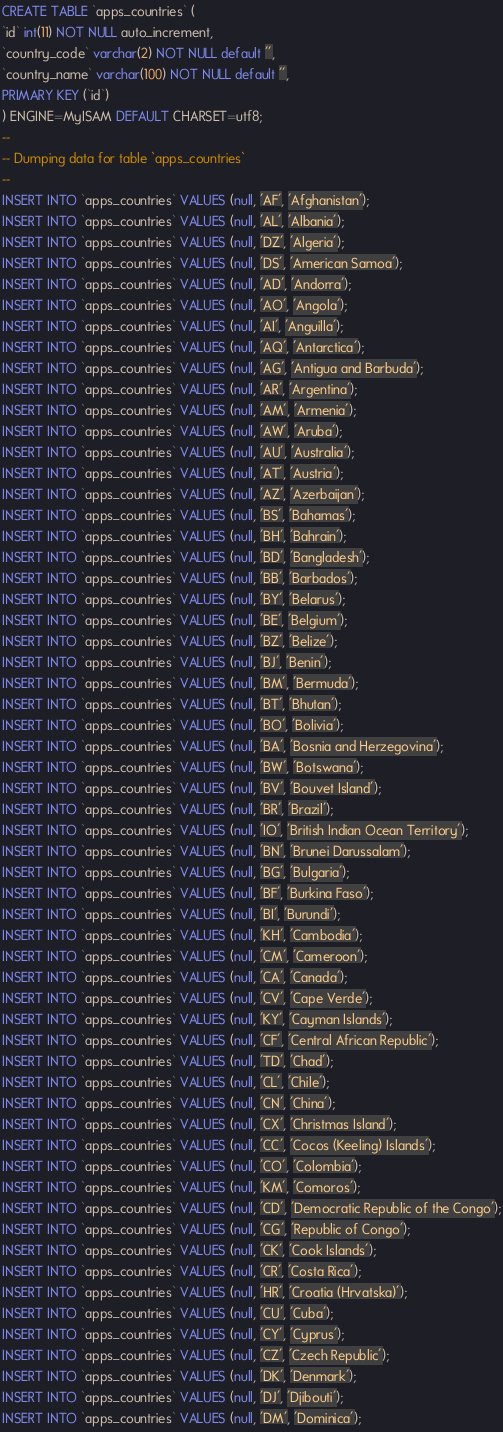<code> <loc_0><loc_0><loc_500><loc_500><_SQL_>CREATE TABLE `apps_countries` (
`id` int(11) NOT NULL auto_increment,
`country_code` varchar(2) NOT NULL default '',
`country_name` varchar(100) NOT NULL default '',
PRIMARY KEY (`id`)
) ENGINE=MyISAM DEFAULT CHARSET=utf8;
-- 
-- Dumping data for table `apps_countries`
-- 
INSERT INTO `apps_countries` VALUES (null, 'AF', 'Afghanistan');
INSERT INTO `apps_countries` VALUES (null, 'AL', 'Albania');
INSERT INTO `apps_countries` VALUES (null, 'DZ', 'Algeria');
INSERT INTO `apps_countries` VALUES (null, 'DS', 'American Samoa');
INSERT INTO `apps_countries` VALUES (null, 'AD', 'Andorra');
INSERT INTO `apps_countries` VALUES (null, 'AO', 'Angola');
INSERT INTO `apps_countries` VALUES (null, 'AI', 'Anguilla');
INSERT INTO `apps_countries` VALUES (null, 'AQ', 'Antarctica');
INSERT INTO `apps_countries` VALUES (null, 'AG', 'Antigua and Barbuda');
INSERT INTO `apps_countries` VALUES (null, 'AR', 'Argentina');
INSERT INTO `apps_countries` VALUES (null, 'AM', 'Armenia');
INSERT INTO `apps_countries` VALUES (null, 'AW', 'Aruba');
INSERT INTO `apps_countries` VALUES (null, 'AU', 'Australia');
INSERT INTO `apps_countries` VALUES (null, 'AT', 'Austria');
INSERT INTO `apps_countries` VALUES (null, 'AZ', 'Azerbaijan');
INSERT INTO `apps_countries` VALUES (null, 'BS', 'Bahamas');
INSERT INTO `apps_countries` VALUES (null, 'BH', 'Bahrain');
INSERT INTO `apps_countries` VALUES (null, 'BD', 'Bangladesh');
INSERT INTO `apps_countries` VALUES (null, 'BB', 'Barbados');
INSERT INTO `apps_countries` VALUES (null, 'BY', 'Belarus');
INSERT INTO `apps_countries` VALUES (null, 'BE', 'Belgium');
INSERT INTO `apps_countries` VALUES (null, 'BZ', 'Belize');
INSERT INTO `apps_countries` VALUES (null, 'BJ', 'Benin');
INSERT INTO `apps_countries` VALUES (null, 'BM', 'Bermuda');
INSERT INTO `apps_countries` VALUES (null, 'BT', 'Bhutan');
INSERT INTO `apps_countries` VALUES (null, 'BO', 'Bolivia');
INSERT INTO `apps_countries` VALUES (null, 'BA', 'Bosnia and Herzegovina');
INSERT INTO `apps_countries` VALUES (null, 'BW', 'Botswana');
INSERT INTO `apps_countries` VALUES (null, 'BV', 'Bouvet Island');
INSERT INTO `apps_countries` VALUES (null, 'BR', 'Brazil');
INSERT INTO `apps_countries` VALUES (null, 'IO', 'British Indian Ocean Territory');
INSERT INTO `apps_countries` VALUES (null, 'BN', 'Brunei Darussalam');
INSERT INTO `apps_countries` VALUES (null, 'BG', 'Bulgaria');
INSERT INTO `apps_countries` VALUES (null, 'BF', 'Burkina Faso');
INSERT INTO `apps_countries` VALUES (null, 'BI', 'Burundi');
INSERT INTO `apps_countries` VALUES (null, 'KH', 'Cambodia');
INSERT INTO `apps_countries` VALUES (null, 'CM', 'Cameroon');
INSERT INTO `apps_countries` VALUES (null, 'CA', 'Canada');
INSERT INTO `apps_countries` VALUES (null, 'CV', 'Cape Verde');
INSERT INTO `apps_countries` VALUES (null, 'KY', 'Cayman Islands');
INSERT INTO `apps_countries` VALUES (null, 'CF', 'Central African Republic');
INSERT INTO `apps_countries` VALUES (null, 'TD', 'Chad');
INSERT INTO `apps_countries` VALUES (null, 'CL', 'Chile');
INSERT INTO `apps_countries` VALUES (null, 'CN', 'China');
INSERT INTO `apps_countries` VALUES (null, 'CX', 'Christmas Island');
INSERT INTO `apps_countries` VALUES (null, 'CC', 'Cocos (Keeling) Islands');
INSERT INTO `apps_countries` VALUES (null, 'CO', 'Colombia');
INSERT INTO `apps_countries` VALUES (null, 'KM', 'Comoros');
INSERT INTO `apps_countries` VALUES (null, 'CD', 'Democratic Republic of the Congo');
INSERT INTO `apps_countries` VALUES (null, 'CG', 'Republic of Congo');
INSERT INTO `apps_countries` VALUES (null, 'CK', 'Cook Islands');
INSERT INTO `apps_countries` VALUES (null, 'CR', 'Costa Rica');
INSERT INTO `apps_countries` VALUES (null, 'HR', 'Croatia (Hrvatska)');
INSERT INTO `apps_countries` VALUES (null, 'CU', 'Cuba');
INSERT INTO `apps_countries` VALUES (null, 'CY', 'Cyprus');
INSERT INTO `apps_countries` VALUES (null, 'CZ', 'Czech Republic');
INSERT INTO `apps_countries` VALUES (null, 'DK', 'Denmark');
INSERT INTO `apps_countries` VALUES (null, 'DJ', 'Djibouti');
INSERT INTO `apps_countries` VALUES (null, 'DM', 'Dominica');</code> 